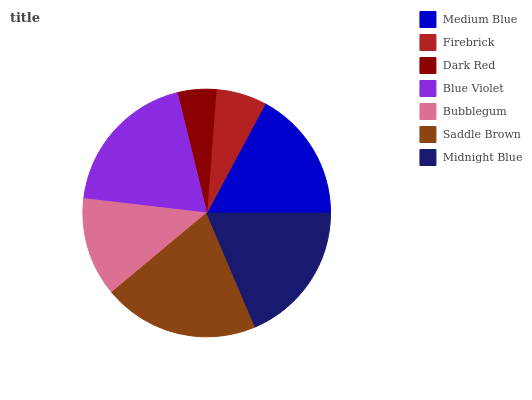Is Dark Red the minimum?
Answer yes or no. Yes. Is Saddle Brown the maximum?
Answer yes or no. Yes. Is Firebrick the minimum?
Answer yes or no. No. Is Firebrick the maximum?
Answer yes or no. No. Is Medium Blue greater than Firebrick?
Answer yes or no. Yes. Is Firebrick less than Medium Blue?
Answer yes or no. Yes. Is Firebrick greater than Medium Blue?
Answer yes or no. No. Is Medium Blue less than Firebrick?
Answer yes or no. No. Is Medium Blue the high median?
Answer yes or no. Yes. Is Medium Blue the low median?
Answer yes or no. Yes. Is Midnight Blue the high median?
Answer yes or no. No. Is Firebrick the low median?
Answer yes or no. No. 